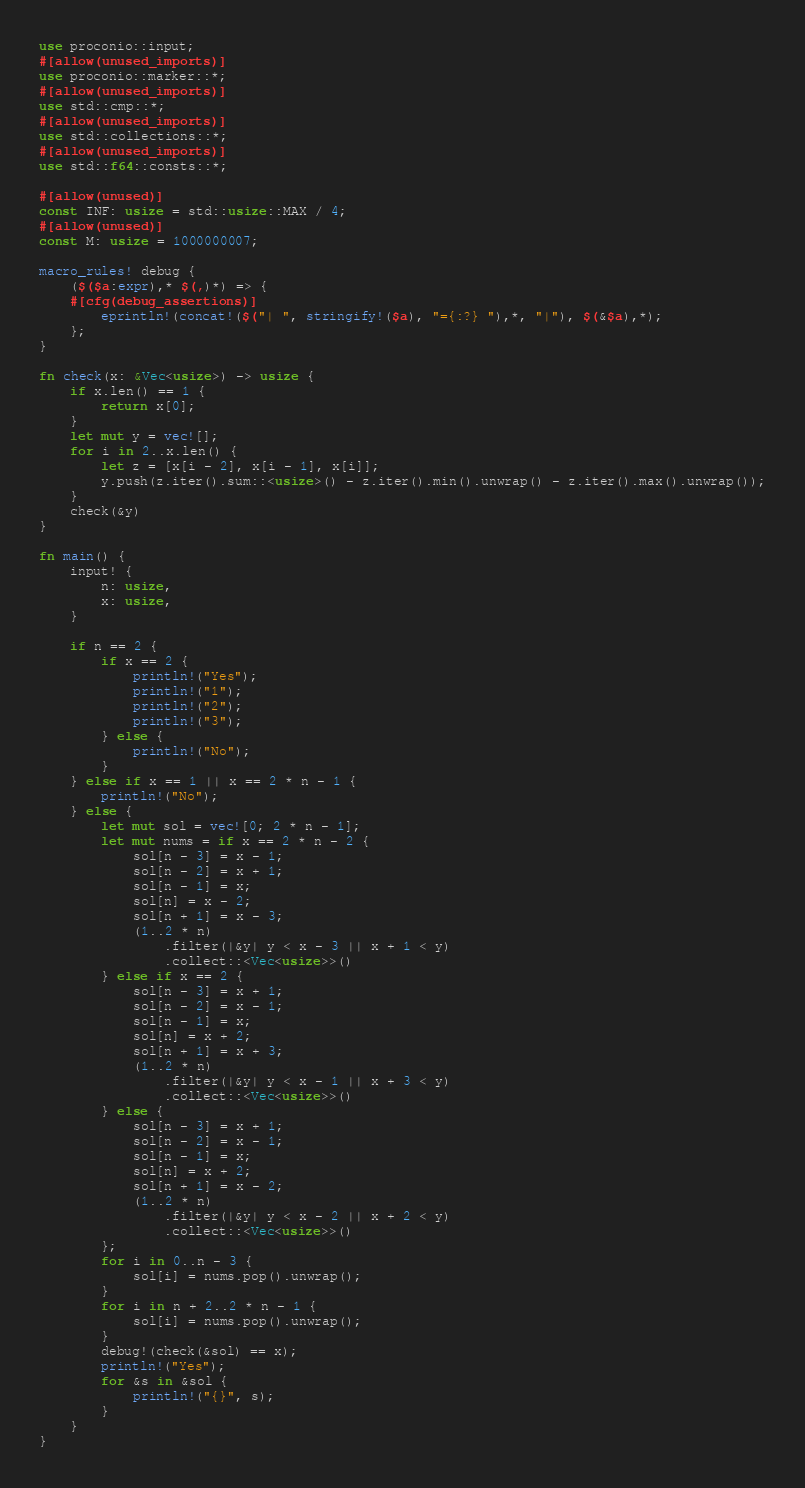Convert code to text. <code><loc_0><loc_0><loc_500><loc_500><_Rust_>use proconio::input;
#[allow(unused_imports)]
use proconio::marker::*;
#[allow(unused_imports)]
use std::cmp::*;
#[allow(unused_imports)]
use std::collections::*;
#[allow(unused_imports)]
use std::f64::consts::*;

#[allow(unused)]
const INF: usize = std::usize::MAX / 4;
#[allow(unused)]
const M: usize = 1000000007;

macro_rules! debug {
    ($($a:expr),* $(,)*) => {
    #[cfg(debug_assertions)]
        eprintln!(concat!($("| ", stringify!($a), "={:?} "),*, "|"), $(&$a),*);
    };
}

fn check(x: &Vec<usize>) -> usize {
    if x.len() == 1 {
        return x[0];
    }
    let mut y = vec![];
    for i in 2..x.len() {
        let z = [x[i - 2], x[i - 1], x[i]];
        y.push(z.iter().sum::<usize>() - z.iter().min().unwrap() - z.iter().max().unwrap());
    }
    check(&y)
}

fn main() {
    input! {
        n: usize,
        x: usize,
    }

    if n == 2 {
        if x == 2 {
            println!("Yes");
            println!("1");
            println!("2");
            println!("3");
        } else {
            println!("No");
        }
    } else if x == 1 || x == 2 * n - 1 {
        println!("No");
    } else {
        let mut sol = vec![0; 2 * n - 1];
        let mut nums = if x == 2 * n - 2 {
            sol[n - 3] = x - 1;
            sol[n - 2] = x + 1;
            sol[n - 1] = x;
            sol[n] = x - 2;
            sol[n + 1] = x - 3;
            (1..2 * n)
                .filter(|&y| y < x - 3 || x + 1 < y)
                .collect::<Vec<usize>>()
        } else if x == 2 {
            sol[n - 3] = x + 1;
            sol[n - 2] = x - 1;
            sol[n - 1] = x;
            sol[n] = x + 2;
            sol[n + 1] = x + 3;
            (1..2 * n)
                .filter(|&y| y < x - 1 || x + 3 < y)
                .collect::<Vec<usize>>()
        } else {
            sol[n - 3] = x + 1;
            sol[n - 2] = x - 1;
            sol[n - 1] = x;
            sol[n] = x + 2;
            sol[n + 1] = x - 2;
            (1..2 * n)
                .filter(|&y| y < x - 2 || x + 2 < y)
                .collect::<Vec<usize>>()
        };
        for i in 0..n - 3 {
            sol[i] = nums.pop().unwrap();
        }
        for i in n + 2..2 * n - 1 {
            sol[i] = nums.pop().unwrap();
        }
        debug!(check(&sol) == x);
        println!("Yes");
        for &s in &sol {
            println!("{}", s);
        }
    }
}
</code> 